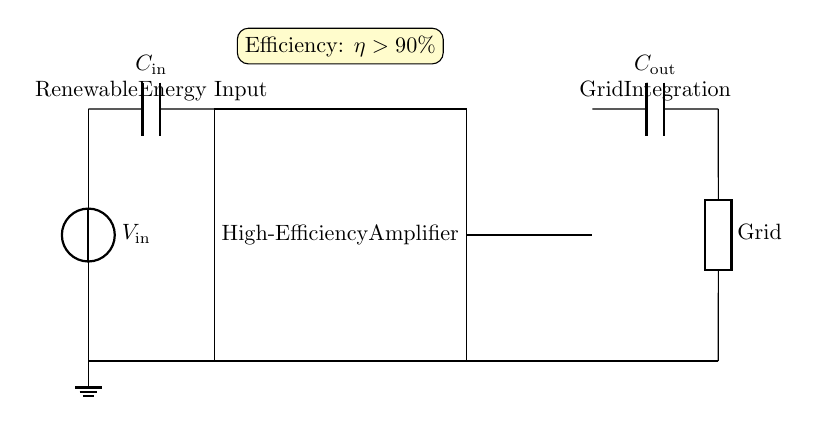What is the input voltage of the circuit? The circuit shows a voltage source labeled as V_in, which represents the input voltage. Therefore, the input voltage is V_in.
Answer: V_in What component is labeled as storing energy at the input? The component labeled as C_in is a capacitor, which is used to store energy. Capacitors in circuits are commonly used for energy storage and filtering applications.
Answer: C_in What is the purpose of the output transformer? The transformer is providing impedance matching and possibly voltage transformation. In this circuit, its function is to integrate the output of the amplifier with the grid.
Answer: Impedance matching What is the efficiency of the amplifier indicated in the diagram? The diagram includes an efficiency indicator stating that the efficiency (η) of the amplifier is greater than 90%. The symbol η denotes efficiency in electronic circuits.
Answer: Greater than 90% How does the load connect to the circuit? The load, which is labeled as Grid, is connected directly between the output of the transformer and ground. This implies that the amplified output from the transformer powers the grid.
Answer: Directly to the transformer output What type of circuit is illustrated in this diagram? This circuit type is a high-efficiency amplifier circuit. It is specifically designed for integrating renewable energy sources into the power grid, making it suitable for energy applications.
Answer: High-efficiency amplifier 